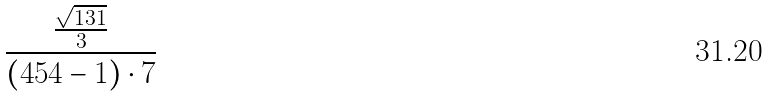Convert formula to latex. <formula><loc_0><loc_0><loc_500><loc_500>\frac { \frac { \sqrt { 1 3 1 } } { 3 } } { ( 4 5 4 - 1 ) \cdot 7 }</formula> 